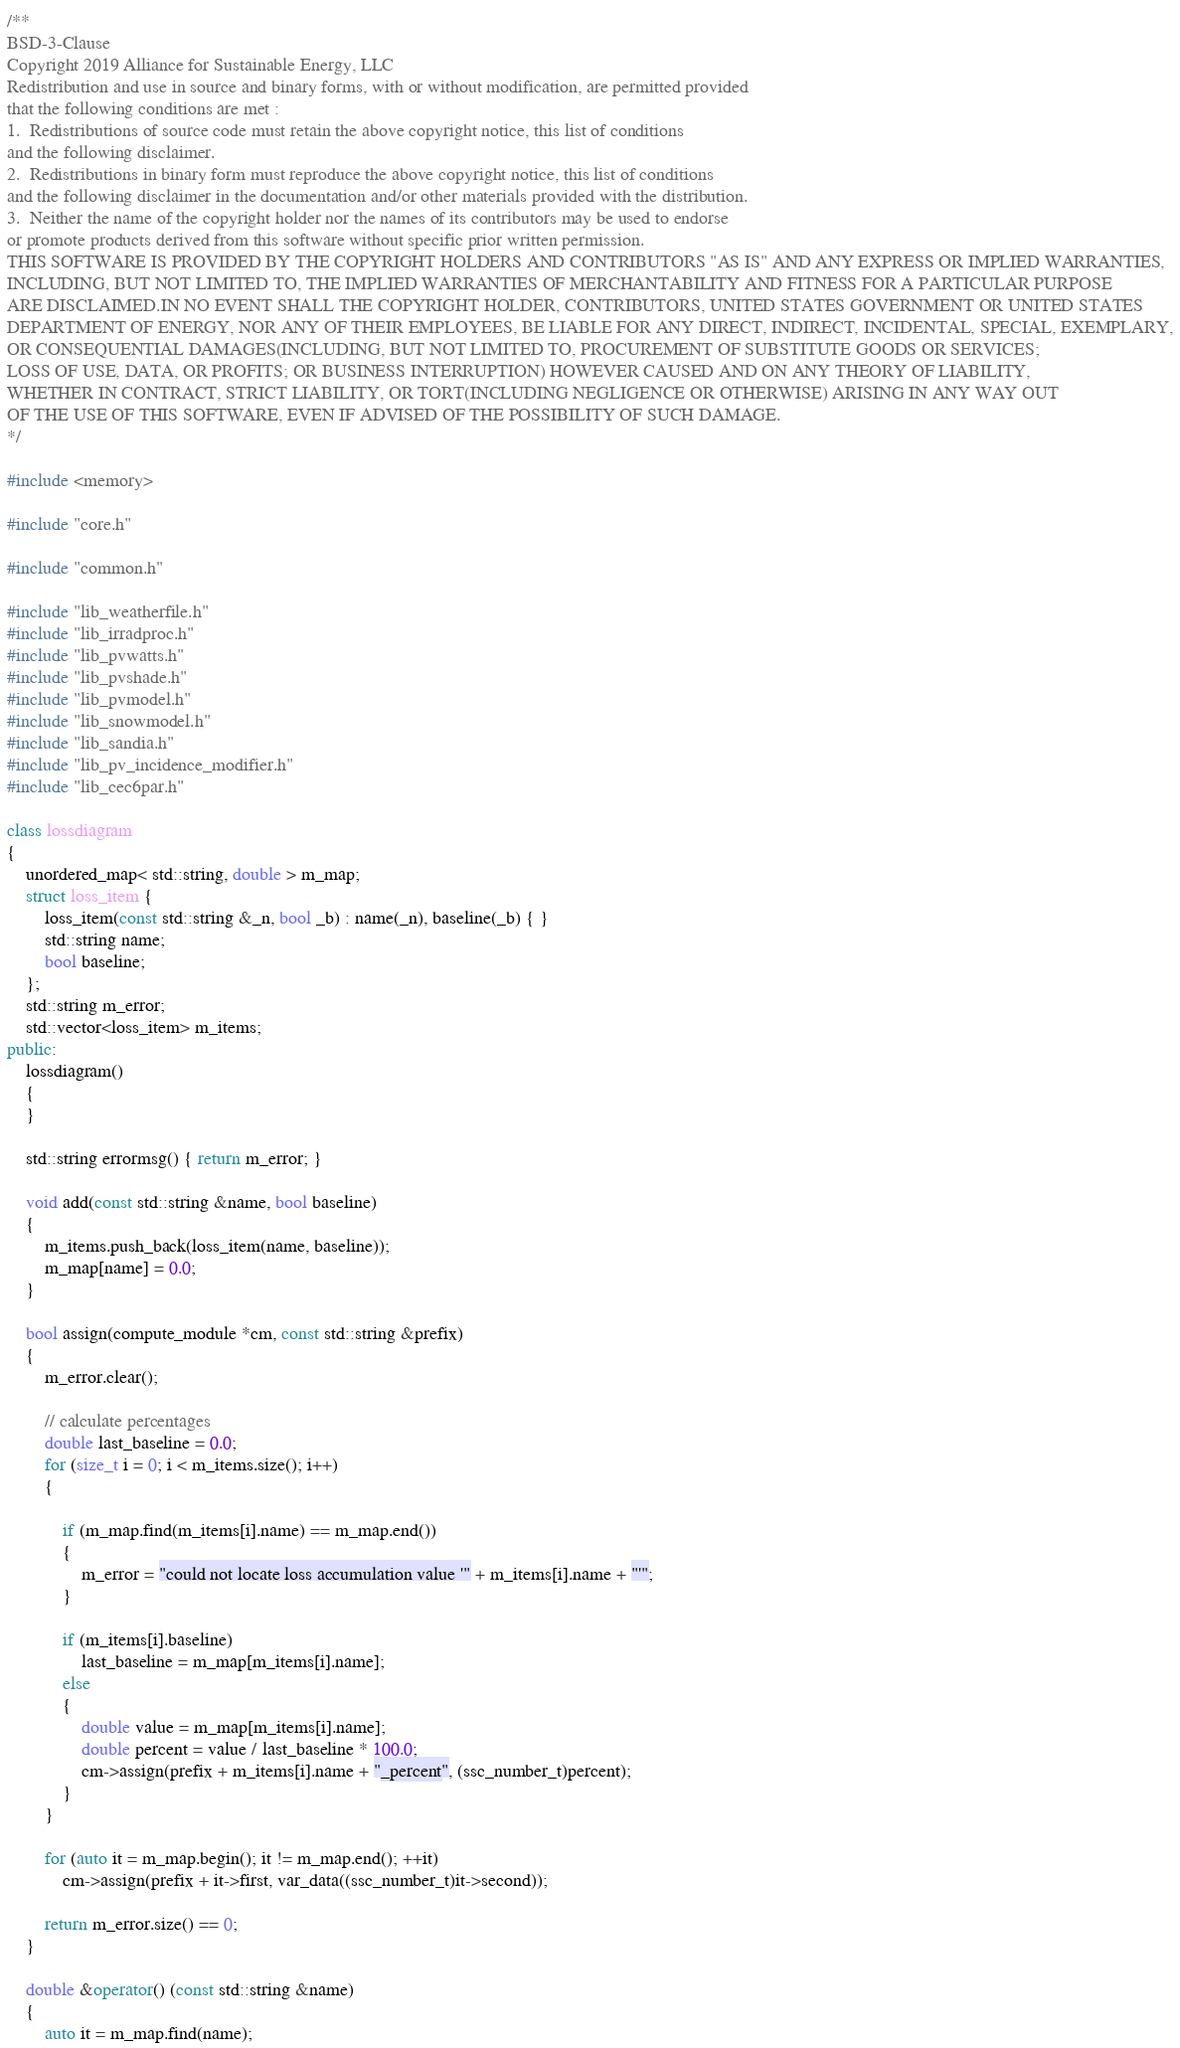Convert code to text. <code><loc_0><loc_0><loc_500><loc_500><_C++_>/**
BSD-3-Clause
Copyright 2019 Alliance for Sustainable Energy, LLC
Redistribution and use in source and binary forms, with or without modification, are permitted provided
that the following conditions are met :
1.	Redistributions of source code must retain the above copyright notice, this list of conditions
and the following disclaimer.
2.	Redistributions in binary form must reproduce the above copyright notice, this list of conditions
and the following disclaimer in the documentation and/or other materials provided with the distribution.
3.	Neither the name of the copyright holder nor the names of its contributors may be used to endorse
or promote products derived from this software without specific prior written permission.
THIS SOFTWARE IS PROVIDED BY THE COPYRIGHT HOLDERS AND CONTRIBUTORS "AS IS" AND ANY EXPRESS OR IMPLIED WARRANTIES,
INCLUDING, BUT NOT LIMITED TO, THE IMPLIED WARRANTIES OF MERCHANTABILITY AND FITNESS FOR A PARTICULAR PURPOSE
ARE DISCLAIMED.IN NO EVENT SHALL THE COPYRIGHT HOLDER, CONTRIBUTORS, UNITED STATES GOVERNMENT OR UNITED STATES
DEPARTMENT OF ENERGY, NOR ANY OF THEIR EMPLOYEES, BE LIABLE FOR ANY DIRECT, INDIRECT, INCIDENTAL, SPECIAL, EXEMPLARY,
OR CONSEQUENTIAL DAMAGES(INCLUDING, BUT NOT LIMITED TO, PROCUREMENT OF SUBSTITUTE GOODS OR SERVICES;
LOSS OF USE, DATA, OR PROFITS; OR BUSINESS INTERRUPTION) HOWEVER CAUSED AND ON ANY THEORY OF LIABILITY,
WHETHER IN CONTRACT, STRICT LIABILITY, OR TORT(INCLUDING NEGLIGENCE OR OTHERWISE) ARISING IN ANY WAY OUT
OF THE USE OF THIS SOFTWARE, EVEN IF ADVISED OF THE POSSIBILITY OF SUCH DAMAGE.
*/

#include <memory>

#include "core.h"

#include "common.h"

#include "lib_weatherfile.h"
#include "lib_irradproc.h"
#include "lib_pvwatts.h"
#include "lib_pvshade.h"
#include "lib_pvmodel.h"
#include "lib_snowmodel.h"
#include "lib_sandia.h"
#include "lib_pv_incidence_modifier.h"
#include "lib_cec6par.h"

class lossdiagram
{
	unordered_map< std::string, double > m_map;
	struct loss_item {
		loss_item(const std::string &_n, bool _b) : name(_n), baseline(_b) { }
		std::string name;
		bool baseline;
	};
	std::string m_error;
	std::vector<loss_item> m_items;
public:
	lossdiagram()
	{
	}

	std::string errormsg() { return m_error; }

	void add(const std::string &name, bool baseline)
	{
		m_items.push_back(loss_item(name, baseline));
		m_map[name] = 0.0;
	}

	bool assign(compute_module *cm, const std::string &prefix)
	{
		m_error.clear();

		// calculate percentages
		double last_baseline = 0.0;
		for (size_t i = 0; i < m_items.size(); i++)
		{

			if (m_map.find(m_items[i].name) == m_map.end())
			{
				m_error = "could not locate loss accumulation value '" + m_items[i].name + "'";
			}

			if (m_items[i].baseline)
				last_baseline = m_map[m_items[i].name];
			else
			{
				double value = m_map[m_items[i].name];
				double percent = value / last_baseline * 100.0;
				cm->assign(prefix + m_items[i].name + "_percent", (ssc_number_t)percent);
			}
		}

		for (auto it = m_map.begin(); it != m_map.end(); ++it)
			cm->assign(prefix + it->first, var_data((ssc_number_t)it->second));

		return m_error.size() == 0;
	}

	double &operator() (const std::string &name)
	{
		auto it = m_map.find(name);</code> 